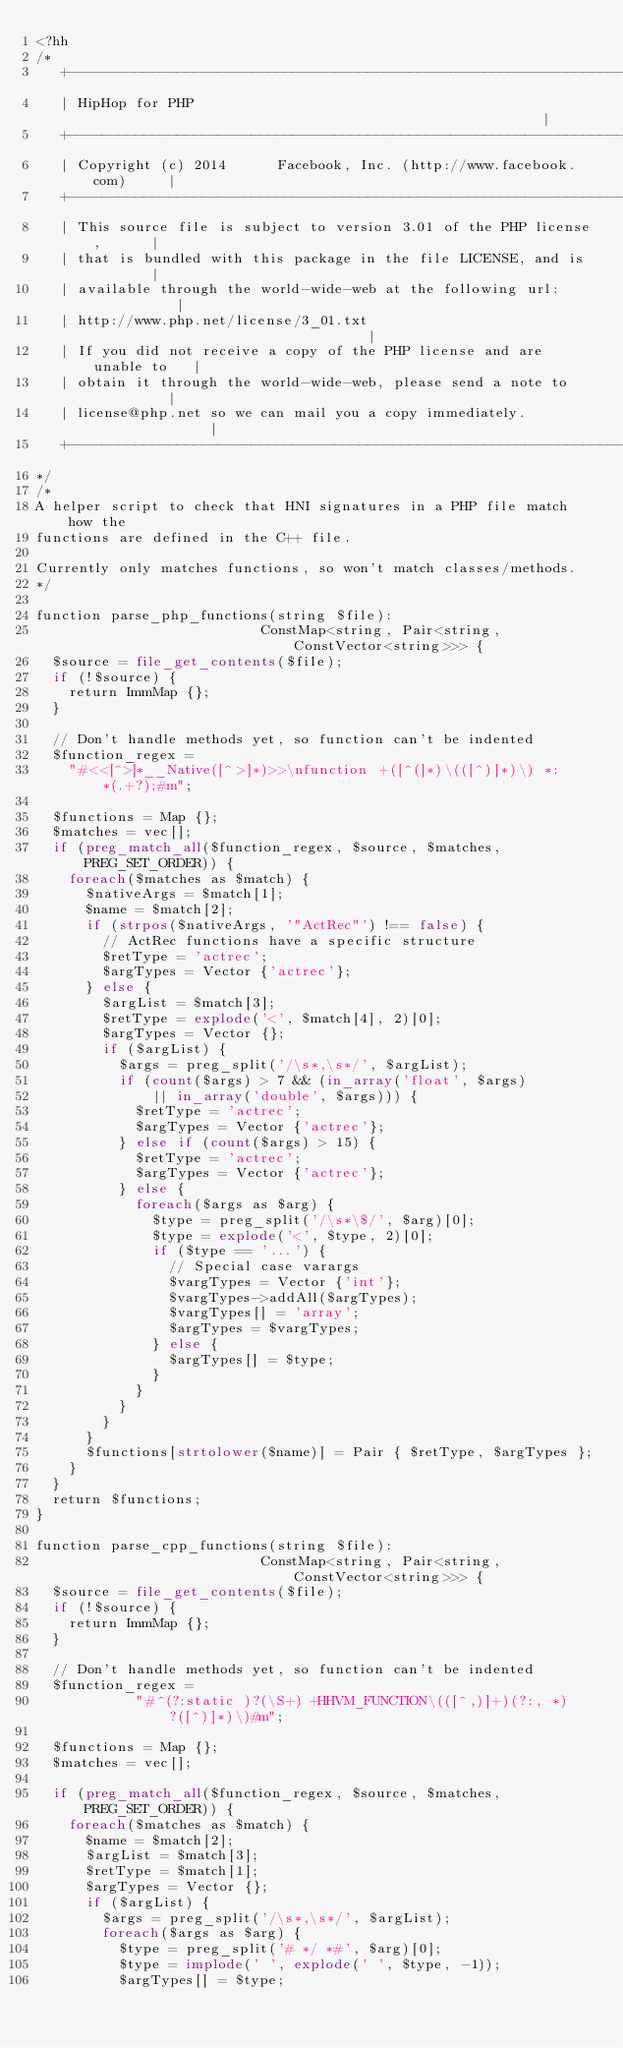<code> <loc_0><loc_0><loc_500><loc_500><_PHP_><?hh
/*
   +----------------------------------------------------------------------+
   | HipHop for PHP                                                       |
   +----------------------------------------------------------------------+
   | Copyright (c) 2014      Facebook, Inc. (http://www.facebook.com)     |
   +----------------------------------------------------------------------+
   | This source file is subject to version 3.01 of the PHP license,      |
   | that is bundled with this package in the file LICENSE, and is        |
   | available through the world-wide-web at the following url:           |
   | http://www.php.net/license/3_01.txt                                  |
   | If you did not receive a copy of the PHP license and are unable to   |
   | obtain it through the world-wide-web, please send a note to          |
   | license@php.net so we can mail you a copy immediately.               |
   +----------------------------------------------------------------------+
*/
/*
A helper script to check that HNI signatures in a PHP file match how the
functions are defined in the C++ file.

Currently only matches functions, so won't match classes/methods.
*/

function parse_php_functions(string $file):
                           ConstMap<string, Pair<string, ConstVector<string>>> {
  $source = file_get_contents($file);
  if (!$source) {
    return ImmMap {};
  }

  // Don't handle methods yet, so function can't be indented
  $function_regex =
    "#<<[^>]*__Native([^>]*)>>\nfunction +([^(]*)\(([^)]*)\) *: *(.+?);#m";

  $functions = Map {};
  $matches = vec[];
  if (preg_match_all($function_regex, $source, $matches, PREG_SET_ORDER)) {
    foreach($matches as $match) {
      $nativeArgs = $match[1];
      $name = $match[2];
      if (strpos($nativeArgs, '"ActRec"') !== false) {
        // ActRec functions have a specific structure
        $retType = 'actrec';
        $argTypes = Vector {'actrec'};
      } else {
        $argList = $match[3];
        $retType = explode('<', $match[4], 2)[0];
        $argTypes = Vector {};
        if ($argList) {
          $args = preg_split('/\s*,\s*/', $argList);
          if (count($args) > 7 && (in_array('float', $args)
              || in_array('double', $args))) {
            $retType = 'actrec';
            $argTypes = Vector {'actrec'};
          } else if (count($args) > 15) {
            $retType = 'actrec';
            $argTypes = Vector {'actrec'};
          } else {
            foreach($args as $arg) {
              $type = preg_split('/\s*\$/', $arg)[0];
              $type = explode('<', $type, 2)[0];
              if ($type == '...') {
                // Special case varargs
                $vargTypes = Vector {'int'};
                $vargTypes->addAll($argTypes);
                $vargTypes[] = 'array';
                $argTypes = $vargTypes;
              } else {
                $argTypes[] = $type;
              }
            }
          }
        }
      }
      $functions[strtolower($name)] = Pair { $retType, $argTypes };
    }
  }
  return $functions;
}

function parse_cpp_functions(string $file):
                           ConstMap<string, Pair<string, ConstVector<string>>> {
  $source = file_get_contents($file);
  if (!$source) {
    return ImmMap {};
  }

  // Don't handle methods yet, so function can't be indented
  $function_regex =
            "#^(?:static )?(\S+) +HHVM_FUNCTION\(([^,)]+)(?:, *)?([^)]*)\)#m";

  $functions = Map {};
  $matches = vec[];

  if (preg_match_all($function_regex, $source, $matches, PREG_SET_ORDER)) {
    foreach($matches as $match) {
      $name = $match[2];
      $argList = $match[3];
      $retType = $match[1];
      $argTypes = Vector {};
      if ($argList) {
        $args = preg_split('/\s*,\s*/', $argList);
        foreach($args as $arg) {
          $type = preg_split('# */ *#', $arg)[0];
          $type = implode(' ', explode(' ', $type, -1));
          $argTypes[] = $type;</code> 